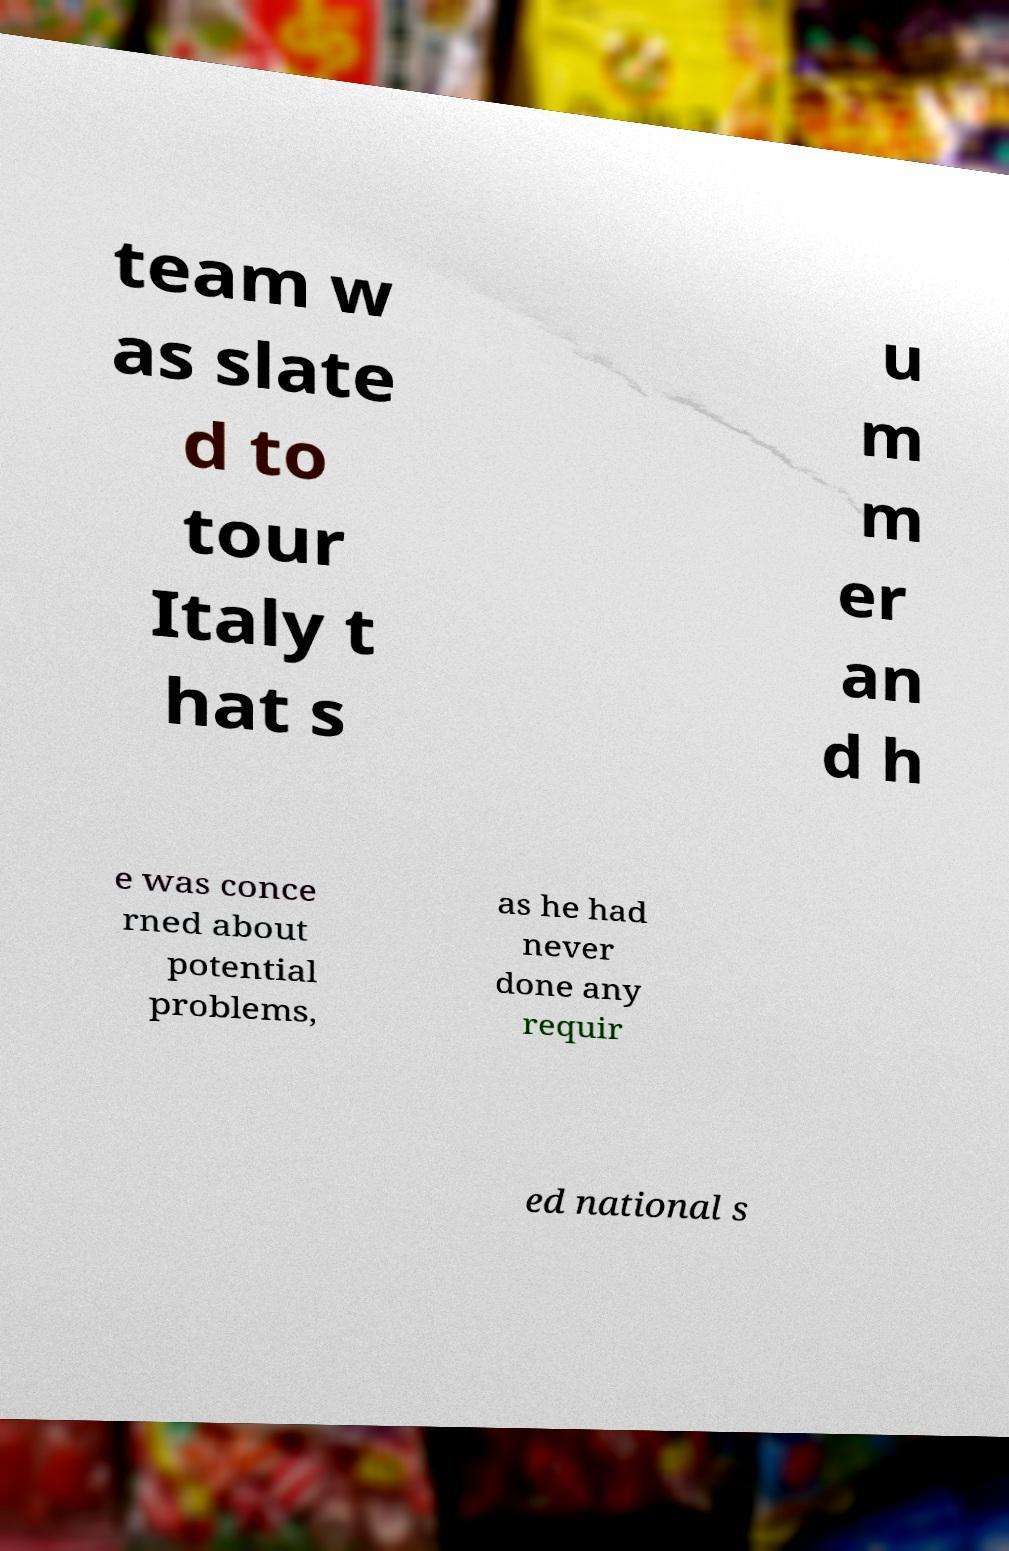Please read and relay the text visible in this image. What does it say? team w as slate d to tour Italy t hat s u m m er an d h e was conce rned about potential problems, as he had never done any requir ed national s 